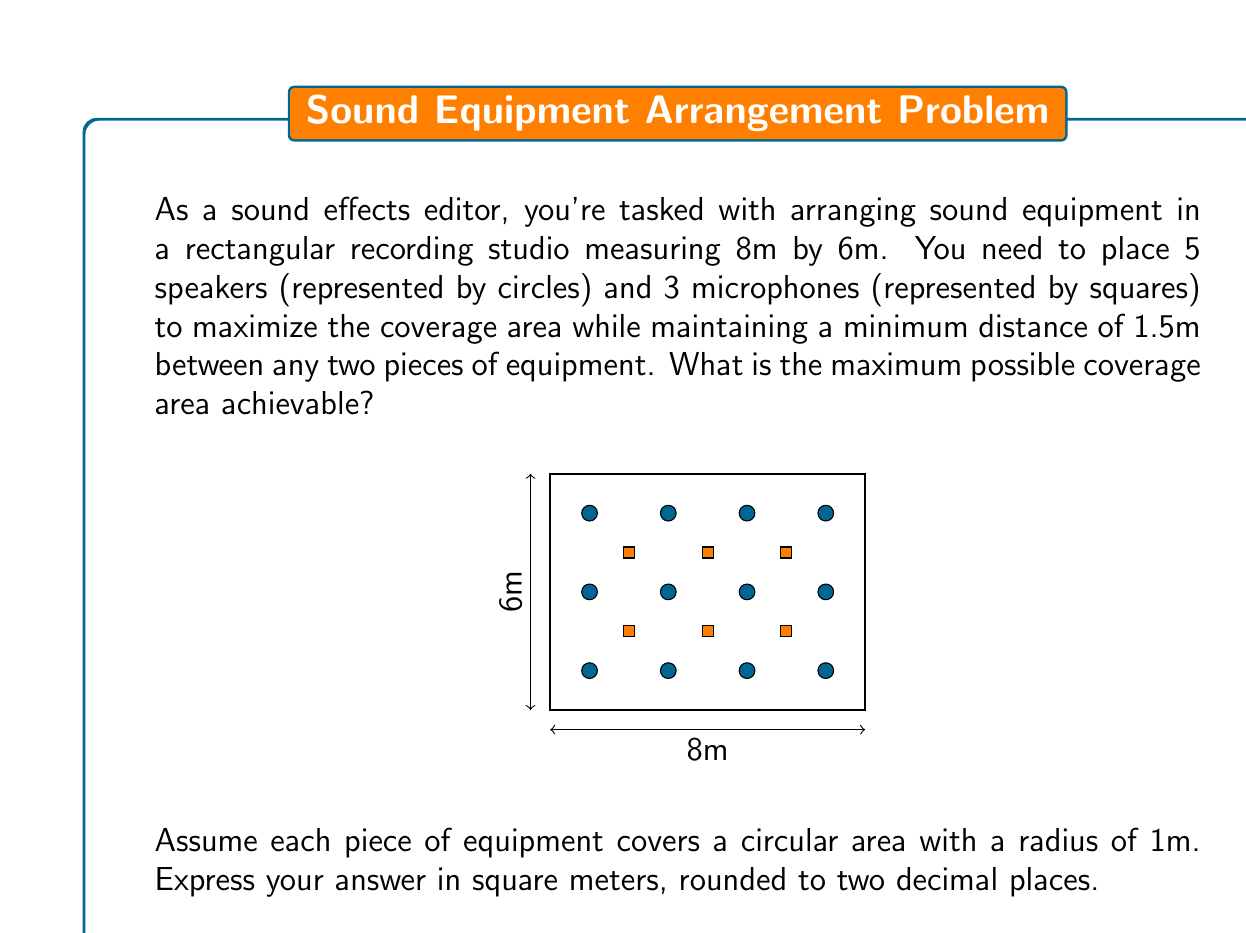Help me with this question. Let's approach this step-by-step:

1) First, we need to calculate the maximum number of equipment pieces that can fit in the room while maintaining the minimum distance:

   - The room area is $8m \times 6m = 48m^2$
   - Each piece of equipment requires a minimum area of $\pi (1.5m)^2 = 7.07m^2$
   - Theoretically, the maximum number of pieces = $48 / 7.07 \approx 6.79$

   However, we're given 8 pieces (5 speakers + 3 microphones), so we'll use all 8.

2) To maximize coverage, we should arrange the equipment in a grid-like pattern. The optimal arrangement would be 3 rows of 3, 3, and 2 pieces.

3) The coverage area of each piece of equipment is:
   
   $A = \pi r^2 = \pi (1m)^2 = \pi m^2$

4) For 8 pieces of equipment, the total coverage area would be:

   $Total Area = 8 \pi m^2$

5) Converting to square meters:

   $Total Area = 8 \pi m^2 = 25.13m^2$

6) Rounding to two decimal places: $25.13m^2$
Answer: $25.13m^2$ 